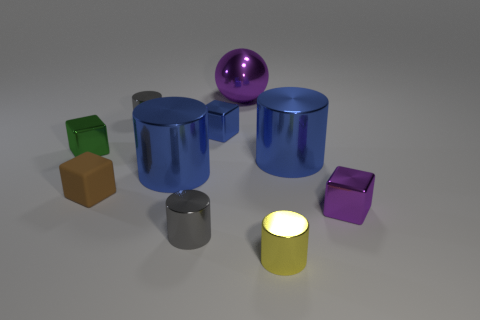There is a tiny brown object that is the same shape as the green object; what is its material?
Your response must be concise. Rubber. The big shiny object that is both in front of the green metal cube and to the right of the small blue metallic cube has what shape?
Give a very brief answer. Cylinder. The brown rubber thing that is in front of the large purple object has what shape?
Provide a short and direct response. Cube. How many metal objects are behind the small blue shiny block and right of the small yellow metal cylinder?
Keep it short and to the point. 0. There is a purple shiny block; does it have the same size as the brown rubber object that is on the left side of the big metal ball?
Your response must be concise. Yes. There is a shiny cube that is right of the large purple object right of the small cylinder that is behind the green object; what size is it?
Your answer should be compact. Small. There is a blue cylinder that is on the left side of the small yellow cylinder; what is its size?
Provide a succinct answer. Large. There is a small yellow thing that is made of the same material as the purple ball; what is its shape?
Give a very brief answer. Cylinder. Do the large blue thing right of the ball and the small purple block have the same material?
Make the answer very short. Yes. How many other objects are there of the same material as the small blue cube?
Keep it short and to the point. 8. 